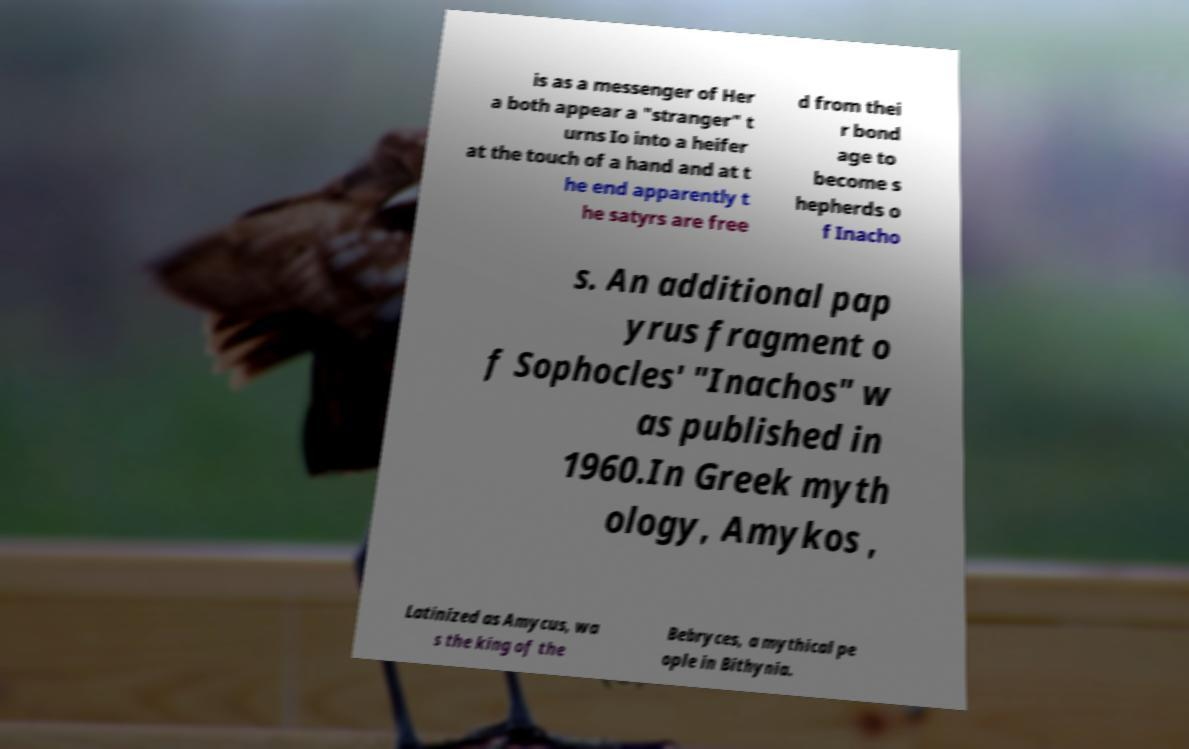For documentation purposes, I need the text within this image transcribed. Could you provide that? is as a messenger of Her a both appear a "stranger" t urns Io into a heifer at the touch of a hand and at t he end apparently t he satyrs are free d from thei r bond age to become s hepherds o f Inacho s. An additional pap yrus fragment o f Sophocles' "Inachos" w as published in 1960.In Greek myth ology, Amykos , Latinized as Amycus, wa s the king of the Bebryces, a mythical pe ople in Bithynia. 